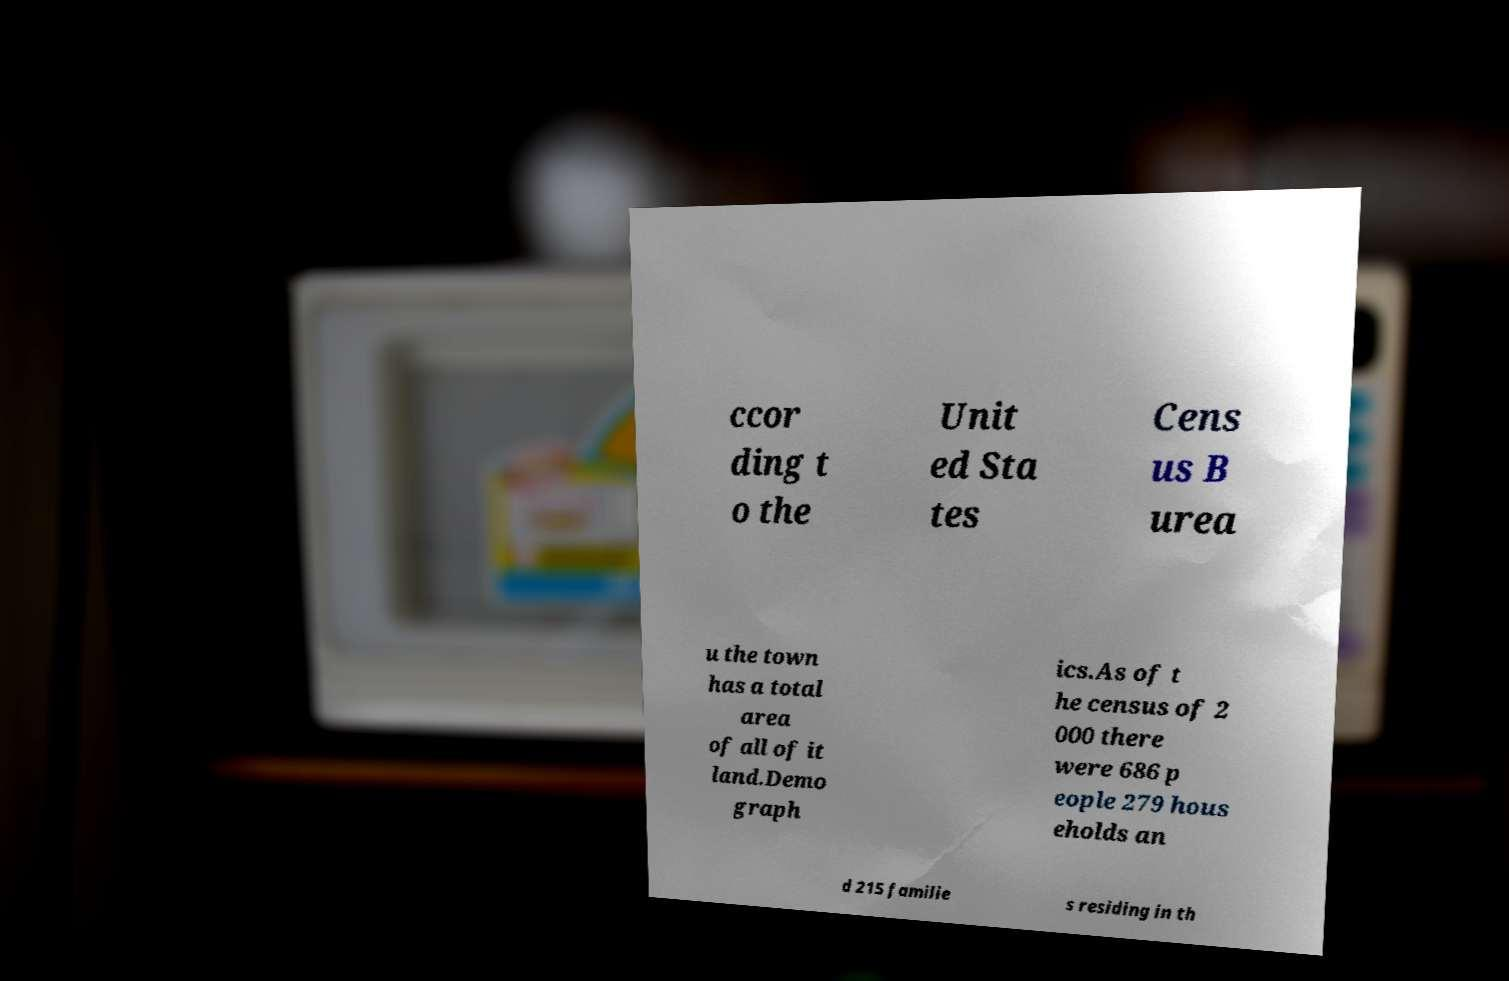Can you accurately transcribe the text from the provided image for me? ccor ding t o the Unit ed Sta tes Cens us B urea u the town has a total area of all of it land.Demo graph ics.As of t he census of 2 000 there were 686 p eople 279 hous eholds an d 215 familie s residing in th 